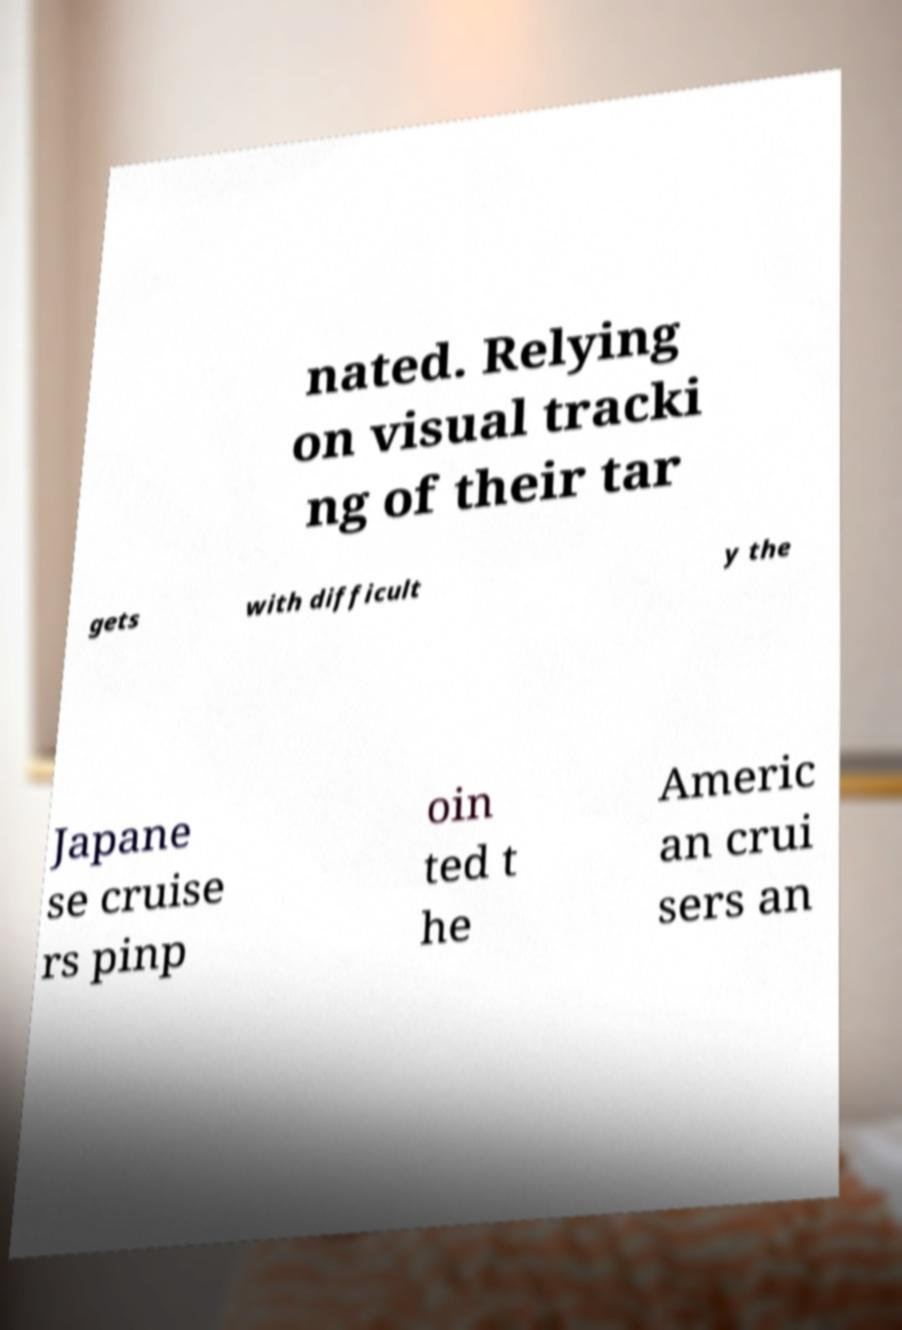Please read and relay the text visible in this image. What does it say? nated. Relying on visual tracki ng of their tar gets with difficult y the Japane se cruise rs pinp oin ted t he Americ an crui sers an 